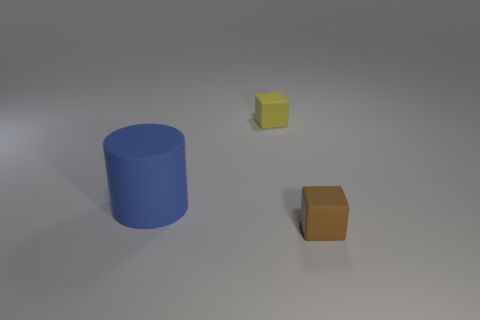Add 2 large matte cylinders. How many objects exist? 5 Subtract all cylinders. How many objects are left? 2 Subtract all cyan balls. Subtract all rubber objects. How many objects are left? 0 Add 1 tiny yellow rubber blocks. How many tiny yellow rubber blocks are left? 2 Add 3 blue things. How many blue things exist? 4 Subtract 0 green blocks. How many objects are left? 3 